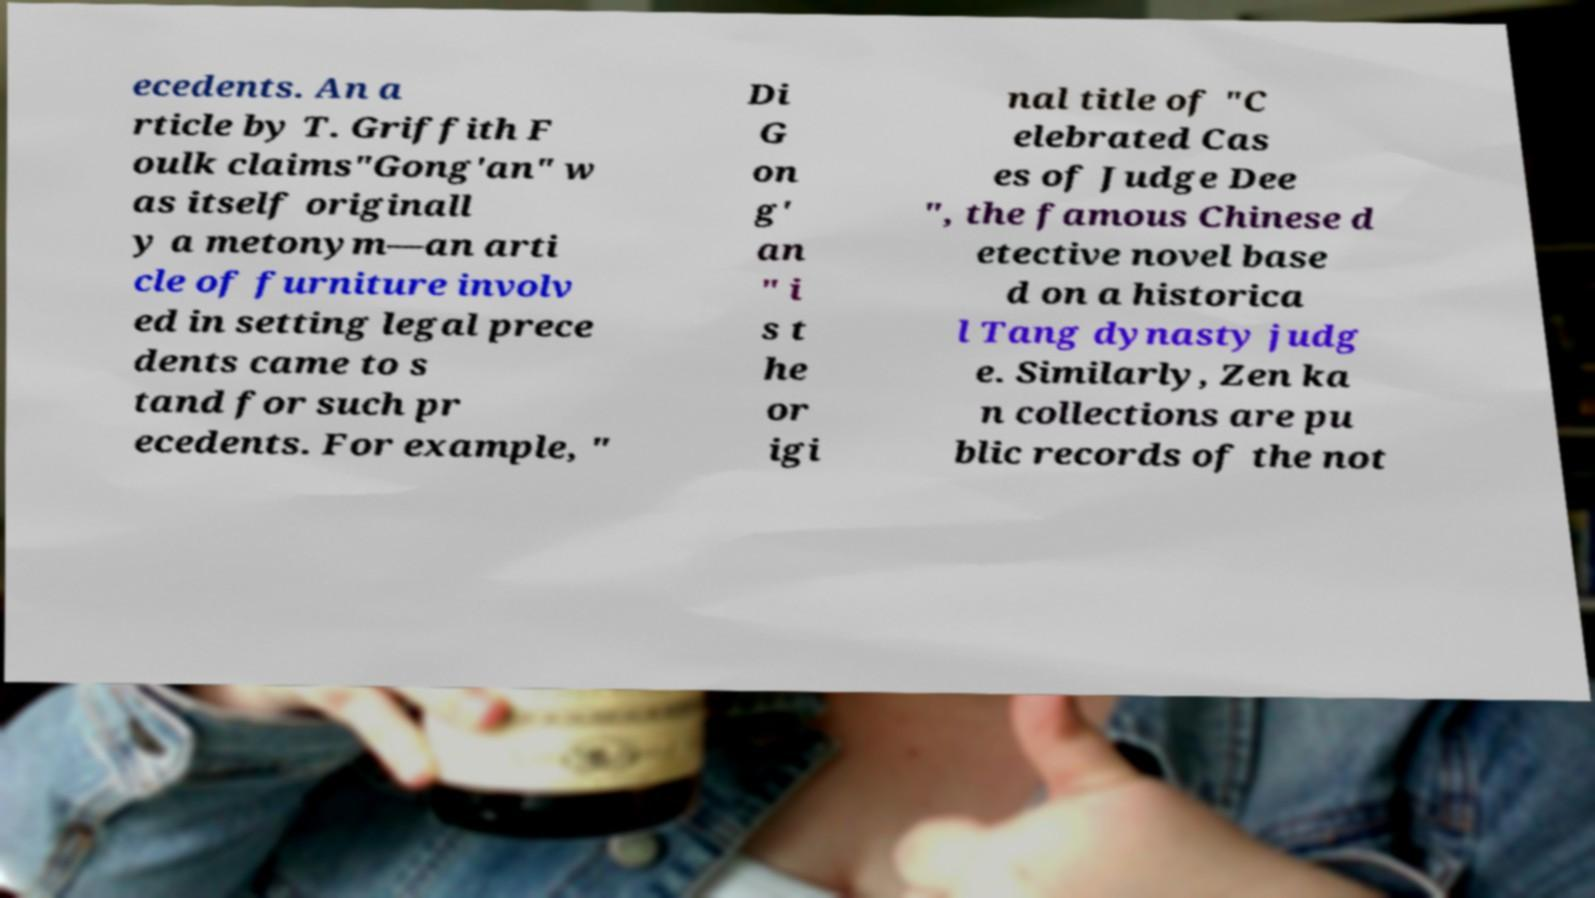Could you extract and type out the text from this image? ecedents. An a rticle by T. Griffith F oulk claims"Gong'an" w as itself originall y a metonym—an arti cle of furniture involv ed in setting legal prece dents came to s tand for such pr ecedents. For example, " Di G on g' an " i s t he or igi nal title of "C elebrated Cas es of Judge Dee ", the famous Chinese d etective novel base d on a historica l Tang dynasty judg e. Similarly, Zen ka n collections are pu blic records of the not 